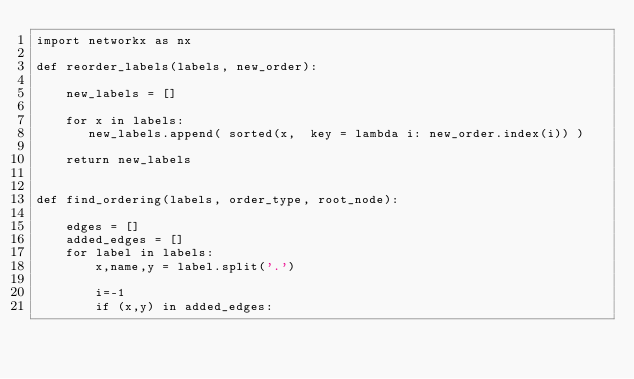<code> <loc_0><loc_0><loc_500><loc_500><_Python_>import networkx as nx

def reorder_labels(labels, new_order):

    new_labels = []

    for x in labels:
       new_labels.append( sorted(x,  key = lambda i: new_order.index(i)) )

    return new_labels


def find_ordering(labels, order_type, root_node):

    edges = []
    added_edges = []
    for label in labels:
        x,name,y = label.split('.')

        i=-1
        if (x,y) in added_edges:</code> 